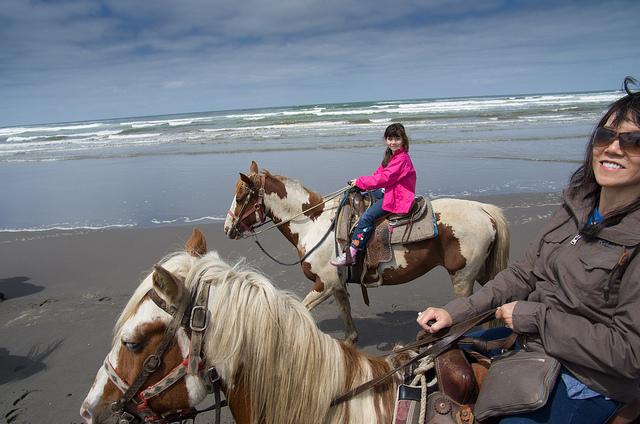Is the horse smiling?
Short answer required. No. Are you able to tell the gender of the rider of the horse?
Write a very short answer. Yes. Is this the beach?
Keep it brief. Yes. What are the people preparing to do?
Quick response, please. Ride horses. Is it a hot day?
Write a very short answer. No. 